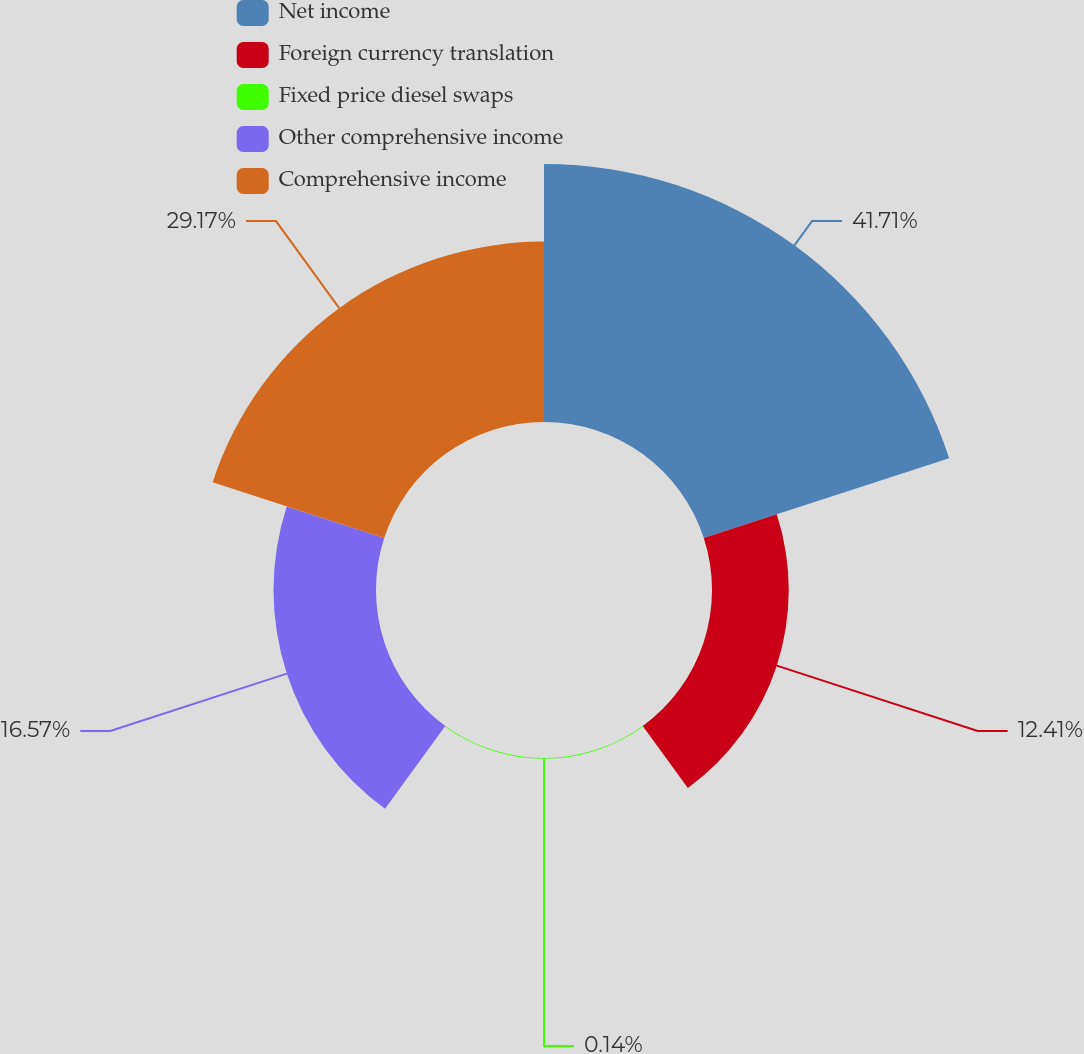Convert chart. <chart><loc_0><loc_0><loc_500><loc_500><pie_chart><fcel>Net income<fcel>Foreign currency translation<fcel>Fixed price diesel swaps<fcel>Other comprehensive income<fcel>Comprehensive income<nl><fcel>41.72%<fcel>12.41%<fcel>0.14%<fcel>16.57%<fcel>29.17%<nl></chart> 